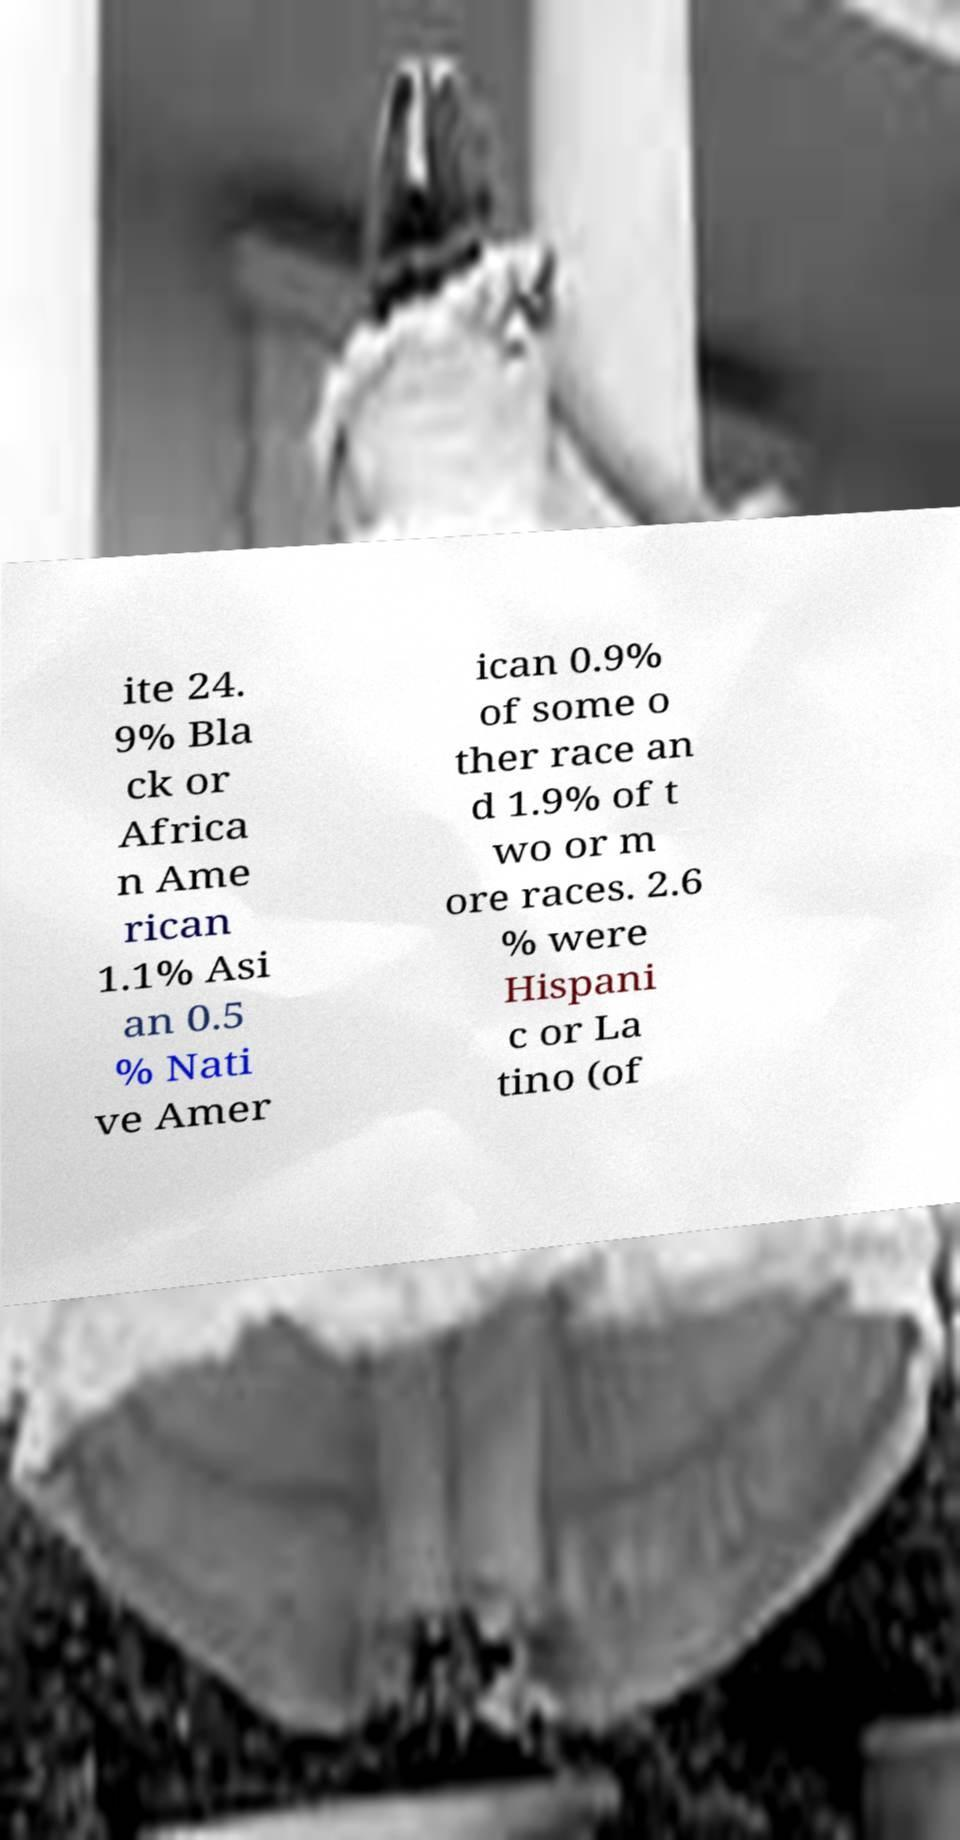For documentation purposes, I need the text within this image transcribed. Could you provide that? ite 24. 9% Bla ck or Africa n Ame rican 1.1% Asi an 0.5 % Nati ve Amer ican 0.9% of some o ther race an d 1.9% of t wo or m ore races. 2.6 % were Hispani c or La tino (of 